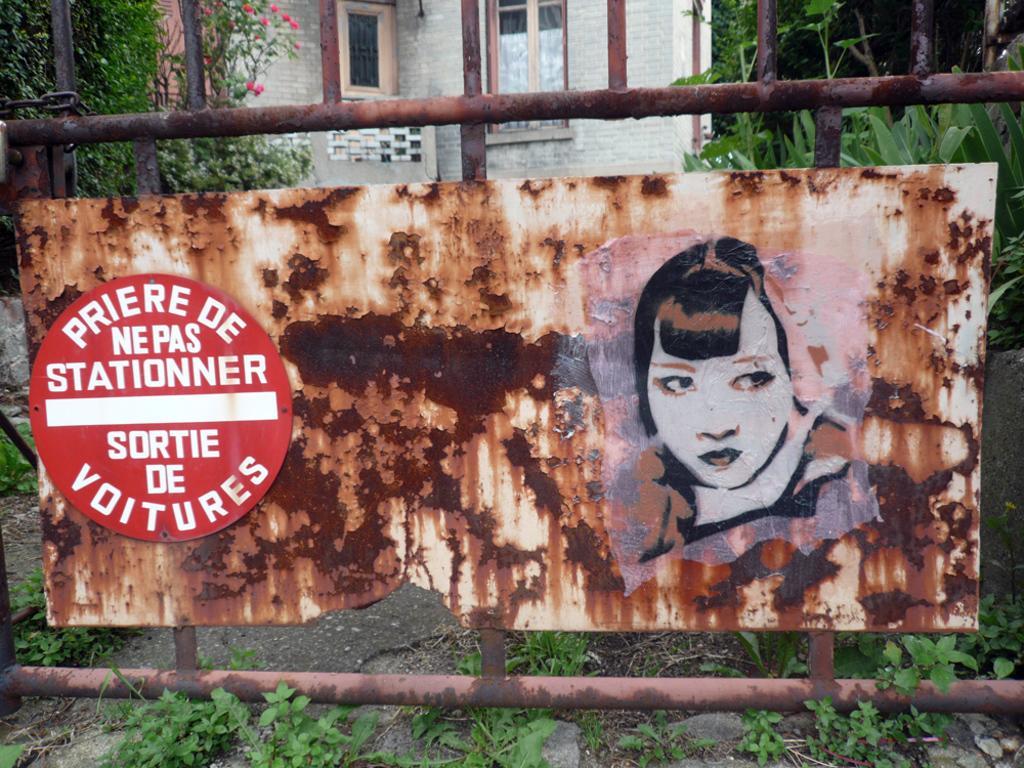Describe this image in one or two sentences. In this image there are boards, building, plants, trees and objects. Something is written on the board. 